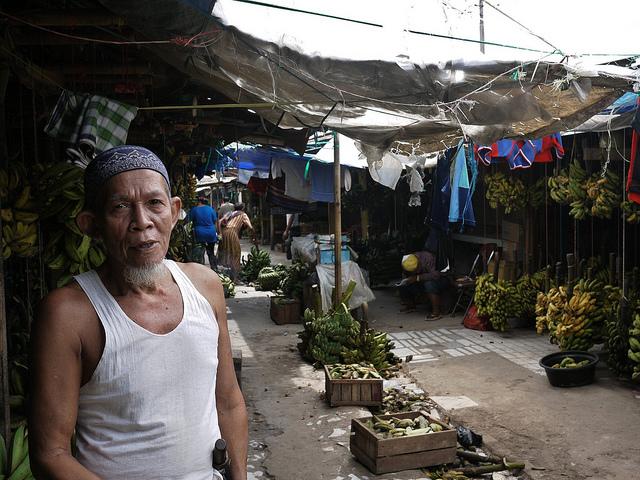How many people are visible in the scene?
Short answer required. 5. What color is the man's head covering?
Give a very brief answer. Blue. Is there a tree stump?
Quick response, please. No. What type of fruit is behind the man?
Keep it brief. Bananas. 